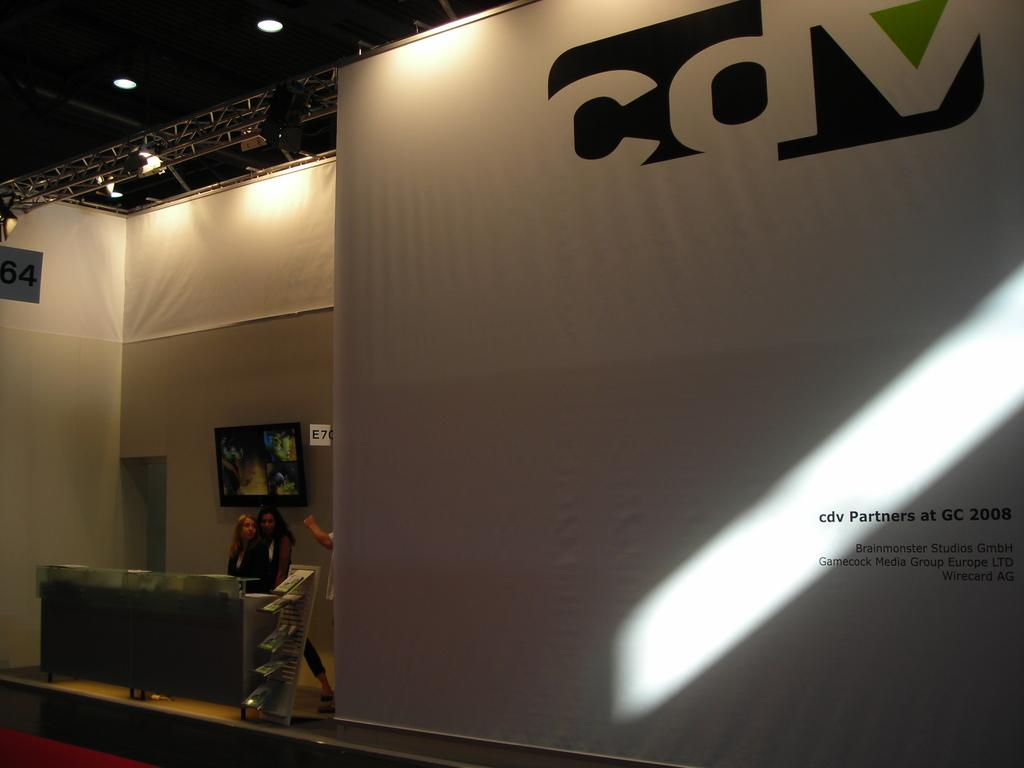Provide a one-sentence caption for the provided image. Two women are standing next to a large stage with a wall that says cdv Partners at GC 2008. 